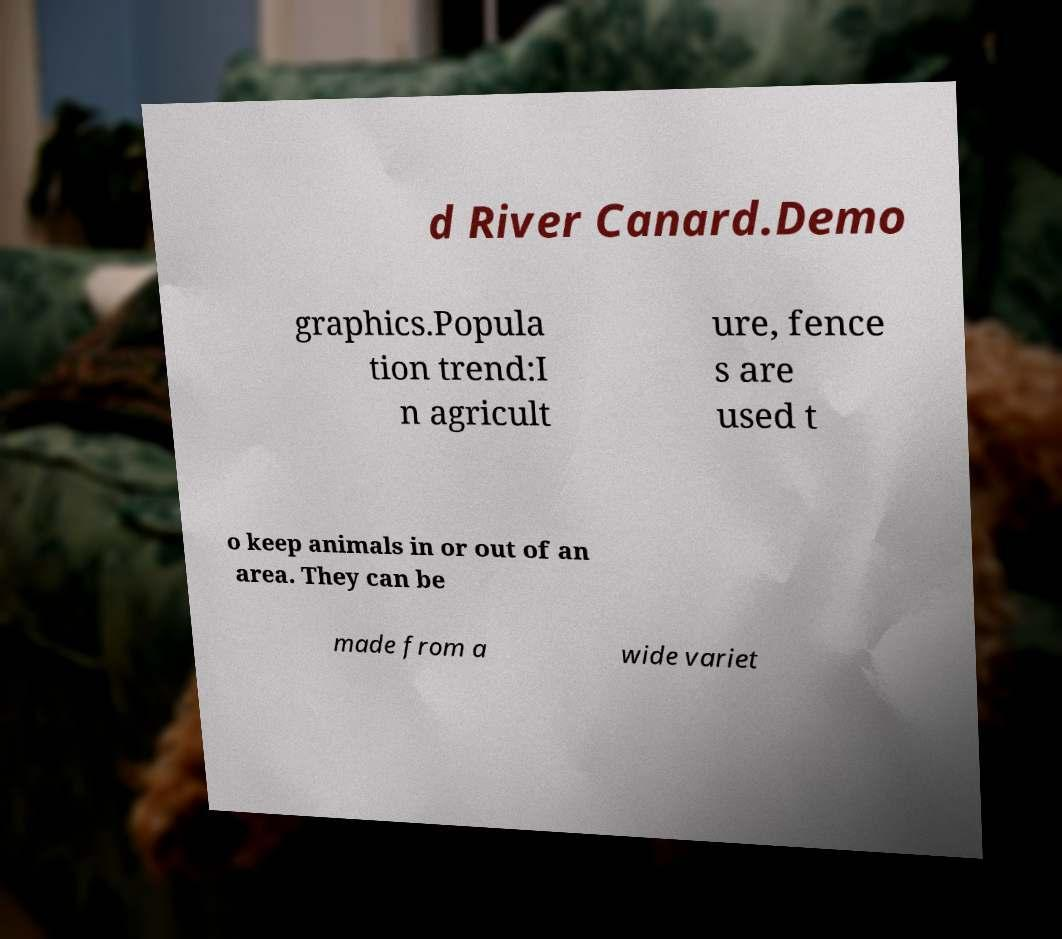Please identify and transcribe the text found in this image. d River Canard.Demo graphics.Popula tion trend:I n agricult ure, fence s are used t o keep animals in or out of an area. They can be made from a wide variet 